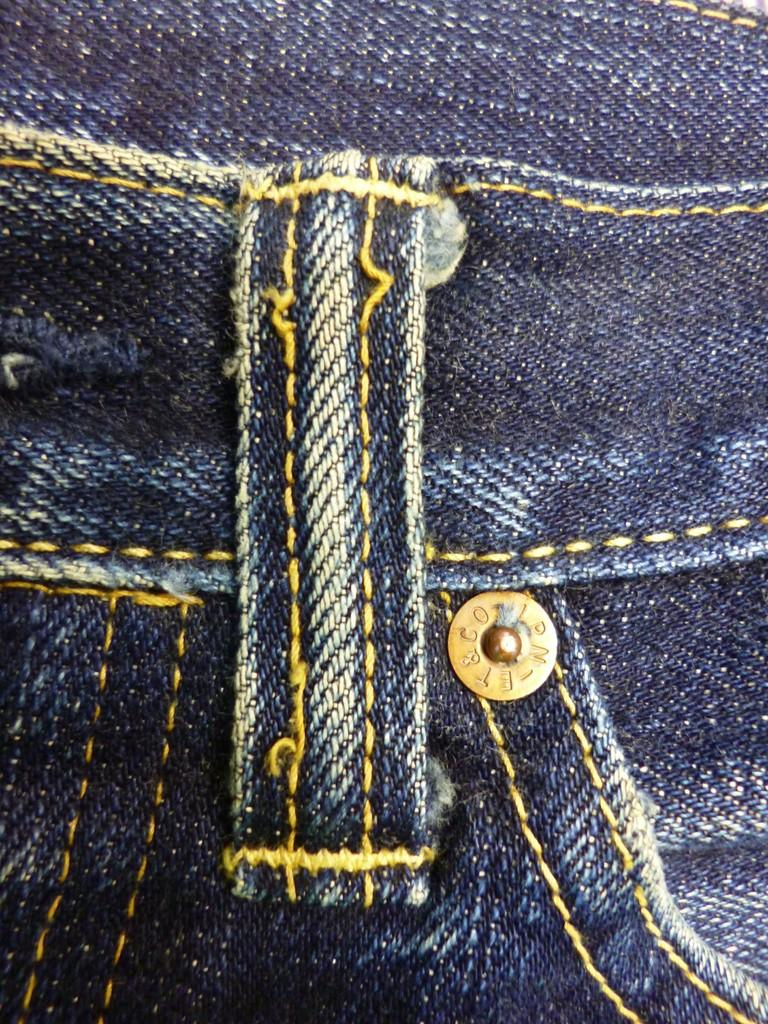What type of clothing item is visible in the image? There is a pair of jeans in the image. What type of dirt can be seen on the jeans in the image? There is no dirt visible on the jeans in the image. What current is flowing through the jeans in the image? Jeans are not capable of conducting electricity, so there is no current flowing through them in the image. 